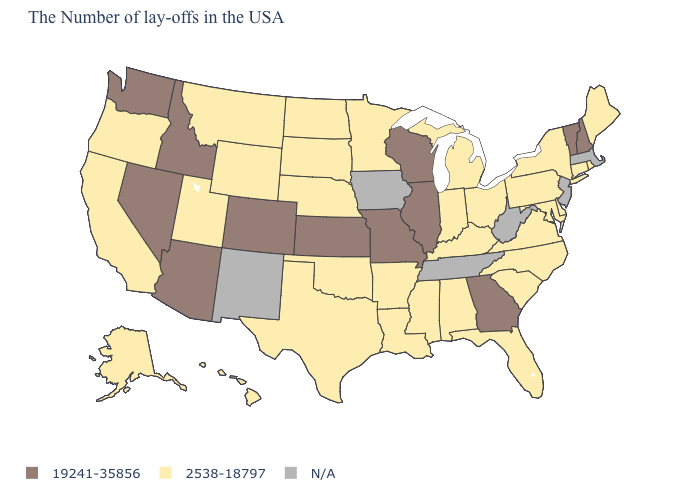What is the value of Nevada?
Short answer required. 19241-35856. How many symbols are there in the legend?
Be succinct. 3. How many symbols are there in the legend?
Give a very brief answer. 3. How many symbols are there in the legend?
Give a very brief answer. 3. What is the highest value in the USA?
Short answer required. 19241-35856. Name the states that have a value in the range 19241-35856?
Answer briefly. New Hampshire, Vermont, Georgia, Wisconsin, Illinois, Missouri, Kansas, Colorado, Arizona, Idaho, Nevada, Washington. Name the states that have a value in the range N/A?
Keep it brief. Massachusetts, New Jersey, West Virginia, Tennessee, Iowa, New Mexico. What is the highest value in the Northeast ?
Give a very brief answer. 19241-35856. What is the value of Vermont?
Keep it brief. 19241-35856. How many symbols are there in the legend?
Answer briefly. 3. What is the value of Maine?
Keep it brief. 2538-18797. Is the legend a continuous bar?
Quick response, please. No. How many symbols are there in the legend?
Be succinct. 3. 